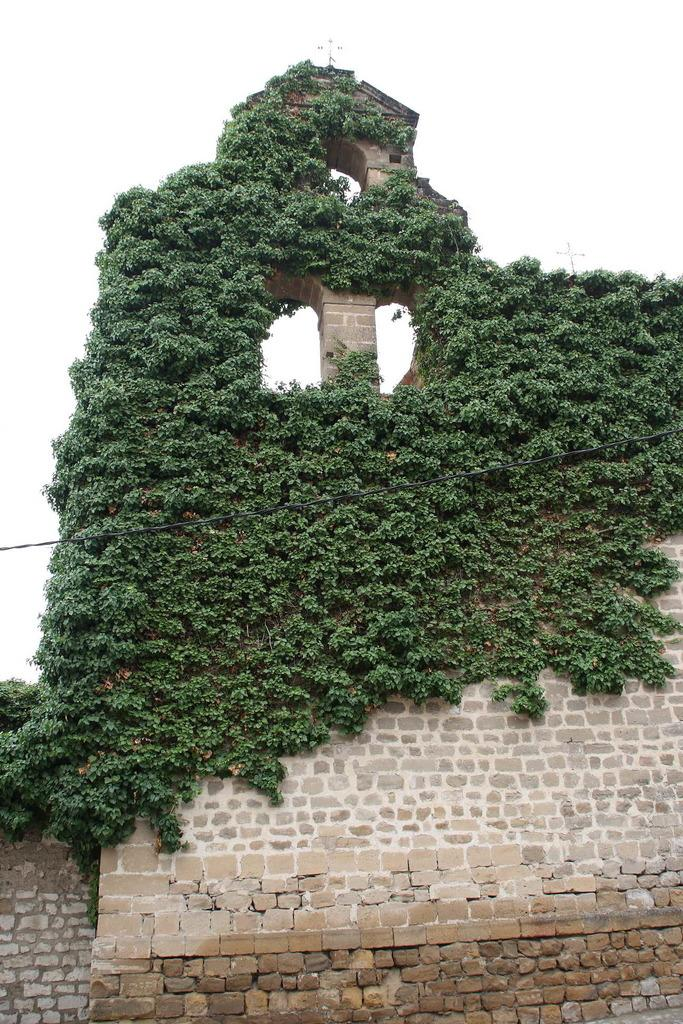What is located at the front of the image? There is a wall in the front of the image. What can be seen on the wall? Plants are present on the wall. What is in the center of the image? There is a wire in the center of the image. What type of bread can be seen on the wall in the image? There is no bread present on the wall in the image; it features plants instead. Can you describe the lip shape of the frog on the wire in the image? There is no frog present on the wire in the image; it is a wire without any animals. 